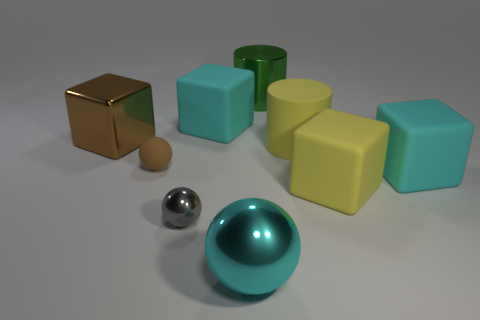Are there any other things that have the same color as the big metal ball?
Your answer should be compact. Yes. Do the big matte thing to the left of the large cyan metallic sphere and the large ball have the same color?
Offer a terse response. Yes. There is a big object that is the same color as the big matte cylinder; what is its shape?
Your response must be concise. Cube. Are there any metal cubes of the same color as the matte ball?
Offer a terse response. Yes. What shape is the big yellow matte object in front of the tiny rubber object?
Make the answer very short. Cube. What number of metallic things are both right of the tiny rubber sphere and on the left side of the cyan metallic thing?
Your answer should be compact. 1. What number of other things are there of the same size as the gray shiny sphere?
Give a very brief answer. 1. There is a large cyan object on the right side of the big green shiny object; is its shape the same as the big shiny thing left of the tiny brown matte thing?
Your answer should be compact. Yes. How many objects are green balls or matte things that are to the left of the yellow rubber cube?
Provide a short and direct response. 3. There is a thing that is behind the yellow cylinder and on the left side of the tiny shiny sphere; what material is it?
Offer a terse response. Metal. 